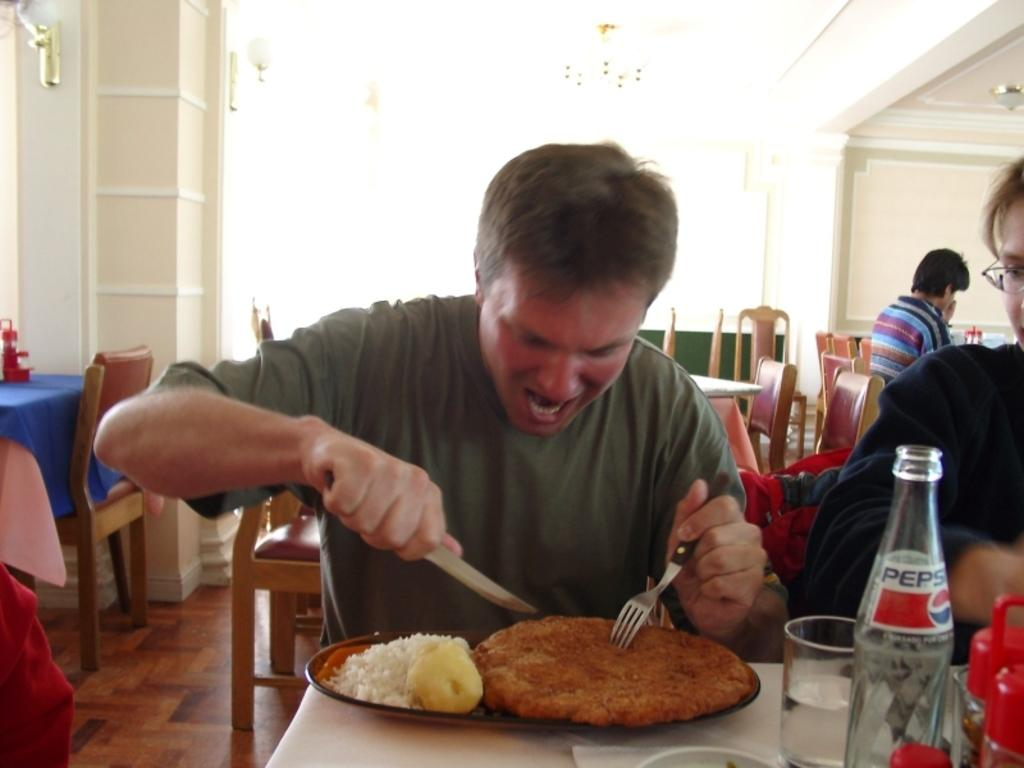Provide a one-sentence caption for the provided image. A man digging into a large plate of food with a bottle of Pepsi. 